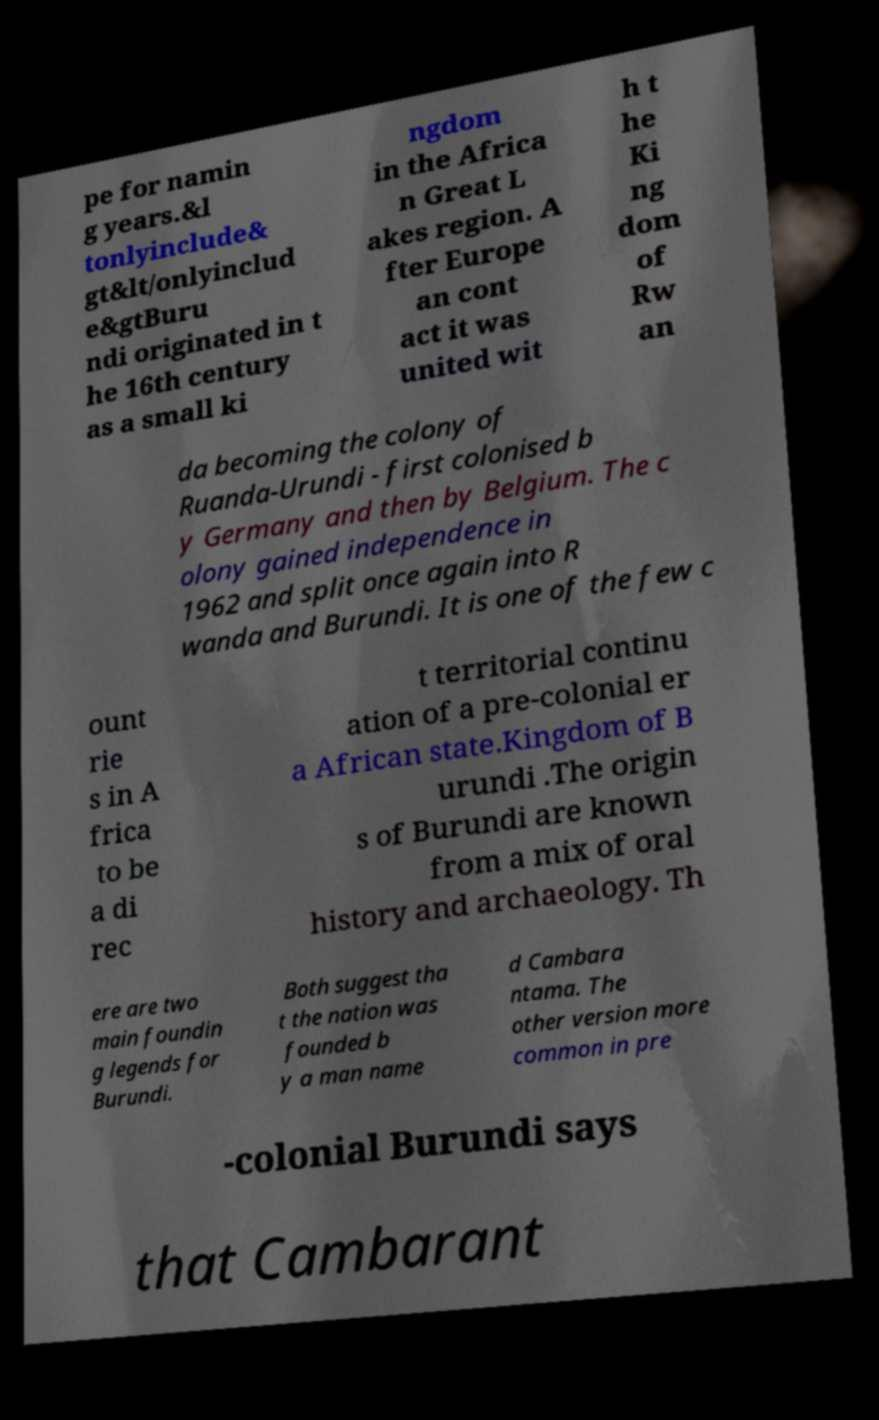Please identify and transcribe the text found in this image. pe for namin g years.&l tonlyinclude& gt&lt/onlyinclud e&gtBuru ndi originated in t he 16th century as a small ki ngdom in the Africa n Great L akes region. A fter Europe an cont act it was united wit h t he Ki ng dom of Rw an da becoming the colony of Ruanda-Urundi - first colonised b y Germany and then by Belgium. The c olony gained independence in 1962 and split once again into R wanda and Burundi. It is one of the few c ount rie s in A frica to be a di rec t territorial continu ation of a pre-colonial er a African state.Kingdom of B urundi .The origin s of Burundi are known from a mix of oral history and archaeology. Th ere are two main foundin g legends for Burundi. Both suggest tha t the nation was founded b y a man name d Cambara ntama. The other version more common in pre -colonial Burundi says that Cambarant 